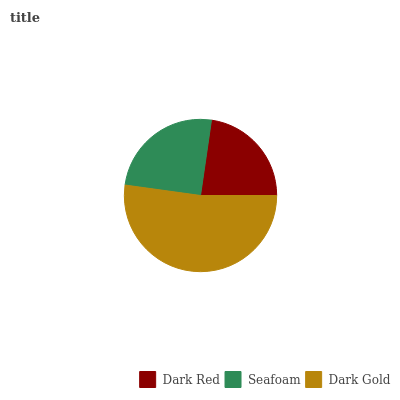Is Dark Red the minimum?
Answer yes or no. Yes. Is Dark Gold the maximum?
Answer yes or no. Yes. Is Seafoam the minimum?
Answer yes or no. No. Is Seafoam the maximum?
Answer yes or no. No. Is Seafoam greater than Dark Red?
Answer yes or no. Yes. Is Dark Red less than Seafoam?
Answer yes or no. Yes. Is Dark Red greater than Seafoam?
Answer yes or no. No. Is Seafoam less than Dark Red?
Answer yes or no. No. Is Seafoam the high median?
Answer yes or no. Yes. Is Seafoam the low median?
Answer yes or no. Yes. Is Dark Gold the high median?
Answer yes or no. No. Is Dark Red the low median?
Answer yes or no. No. 